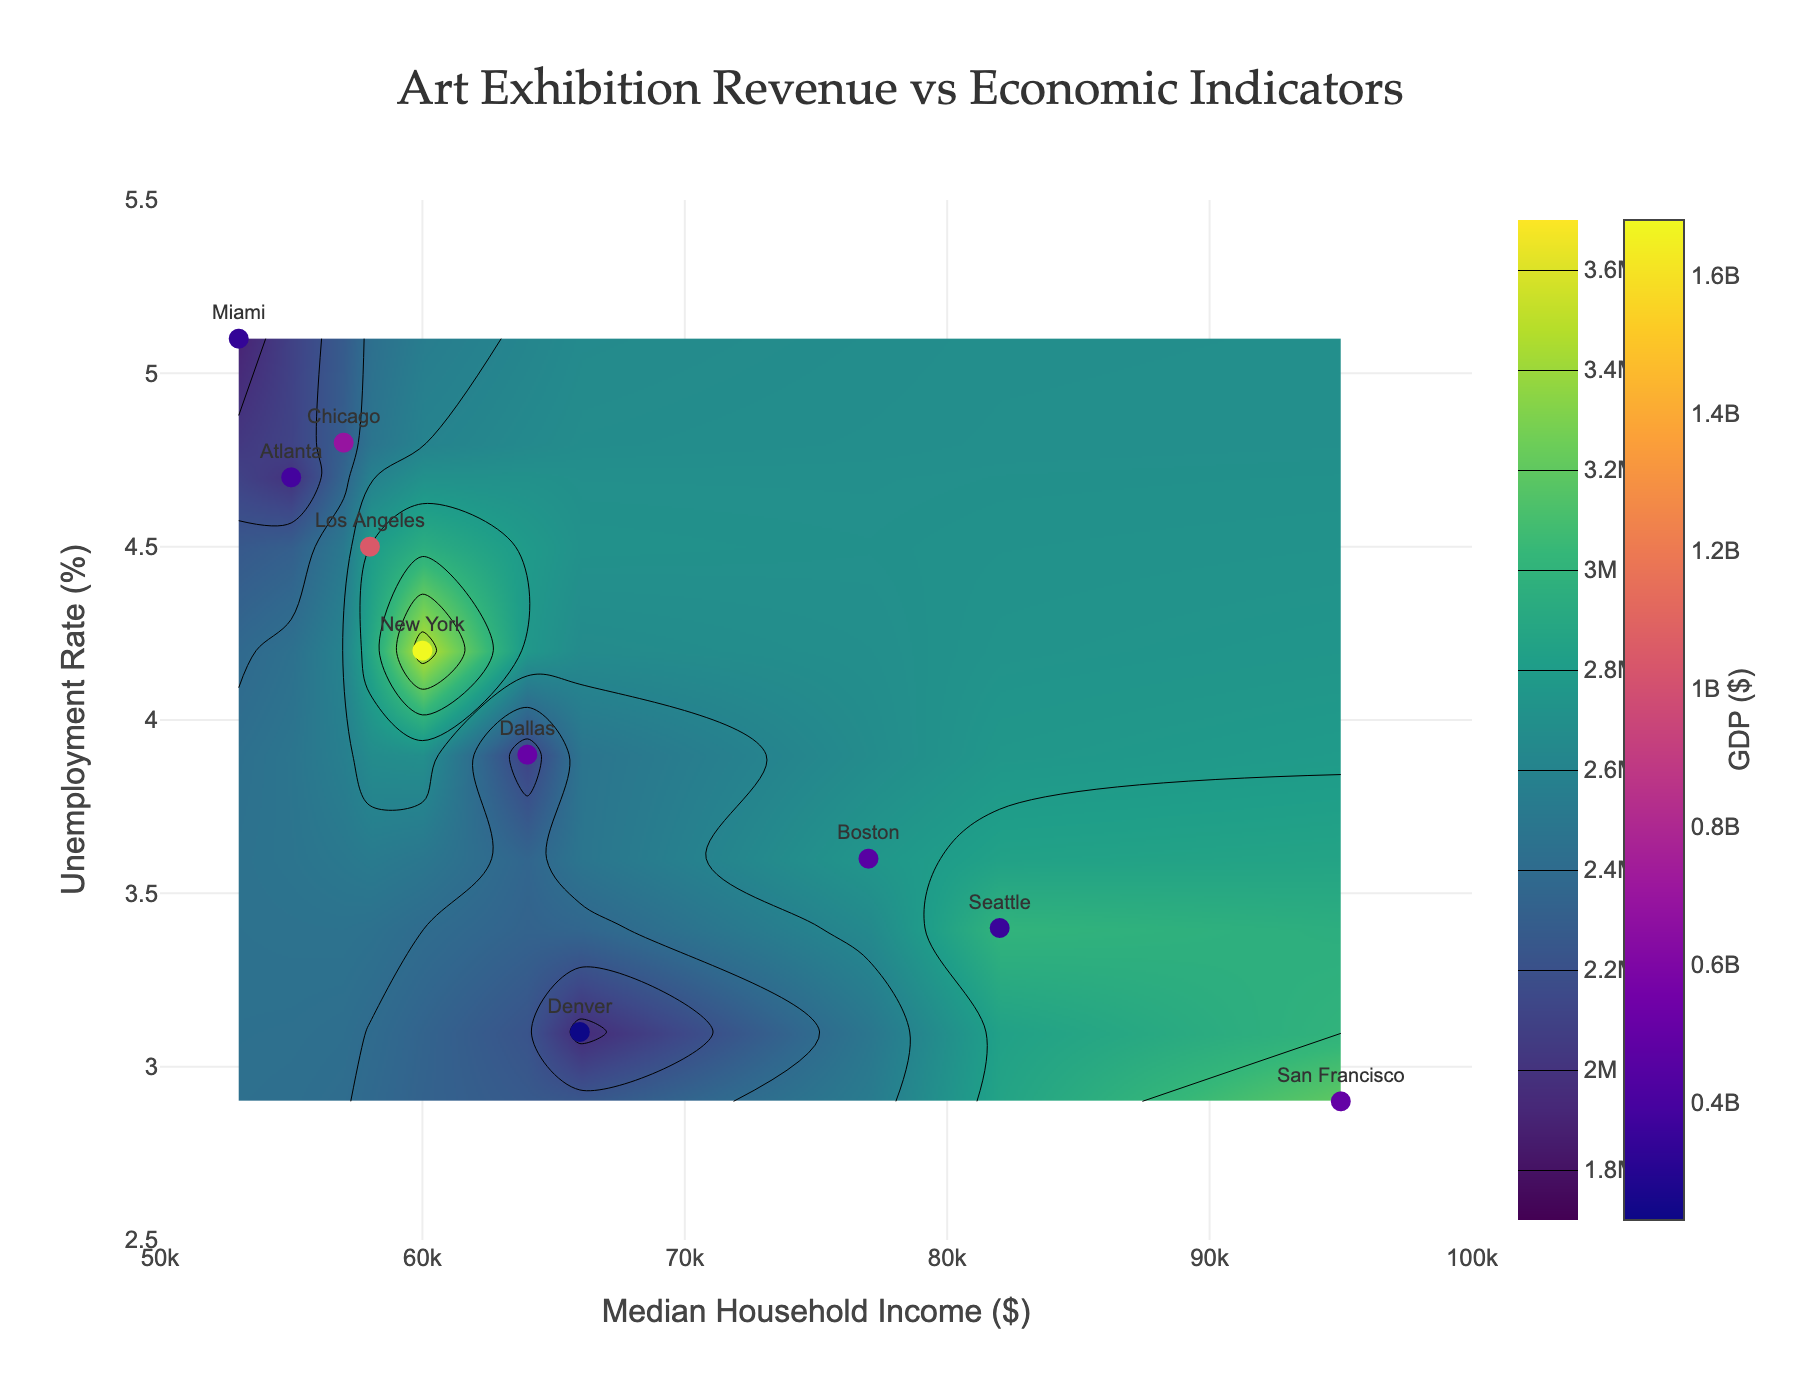Which city has the highest revenue from art exhibitions? New York displays the highest contour level on the plot indicating its revenue of $3,500,000, which is the highest among all the cities (range shown is from $1,800,000 to $3,600,000).
Answer: New York What is the title of the contour plot? The figure's title can be found at the top-center of the plot and it reads "Art Exhibition Revenue vs Economic Indicators".
Answer: Art Exhibition Revenue vs Economic Indicators Which city is represented by the marker located at a median household income of $77,000 and an unemployment rate of 3.6%? The marker with these values of x and y corresponds to Boston as shown on the plot.
Answer: Boston How does the contour of art exhibition revenue change with increasing median household income? As the median household income increases from $50,000 to $100,000, the contour lines indicate a rising trend of art exhibition revenue, suggesting a positive correlation between these variables.
Answer: Rises Which city has the lowest unemployment rate and what is its revenue from exhibitions? The city with the lowest unemployment rate (2.9%) is San Francisco, which has a revenue of about $3,200,000 as indicated by the contour lines.
Answer: San Francisco, $3,200,000 Compare the GDP between Los Angeles and Dallas based on their marker colors. Dallas has a higher GDP (represented by a darker color in the Plasma colorscale) at $511,000,000 compared to Los Angeles's $1,047,000,000. The color scale indicates Los Angeles has a higher GDP.
Answer: Los Angeles has a higher GDP What is the revenue from exhibitions in Atlanta if its median household income and unemployment rate are 55,000 and 4.7% respectively? The contour values at median household income of $55,000 and an unemployment rate of 4.7% intersect around $2,000,000, which corresponds to Atlanta's revenue.
Answer: $2,000,000 Which city roughly falls on the contour line of $2,600,000? The contour line of $2,600,000 visually passes near Boston with a median household income of $77,000 and an unemployment rate of 3.6%.
Answer: Boston Is there a trend between unemployment rate and revenue? Observing the contour lines indicates that higher revenues are generally associated with lower unemployment rates as the lines trend upwards when moving left (lower unemployment) to right (higher revenue).
Answer: Generally, lower unemployment rates correspond to higher revenues 